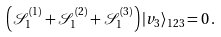Convert formula to latex. <formula><loc_0><loc_0><loc_500><loc_500>\left ( \mathcal { S } _ { 1 } ^ { ( 1 ) } + \mathcal { S } _ { 1 } ^ { ( 2 ) } + \mathcal { S } _ { 1 } ^ { ( 3 ) } \right ) | v _ { 3 } \rangle _ { 1 2 3 } = 0 \, .</formula> 